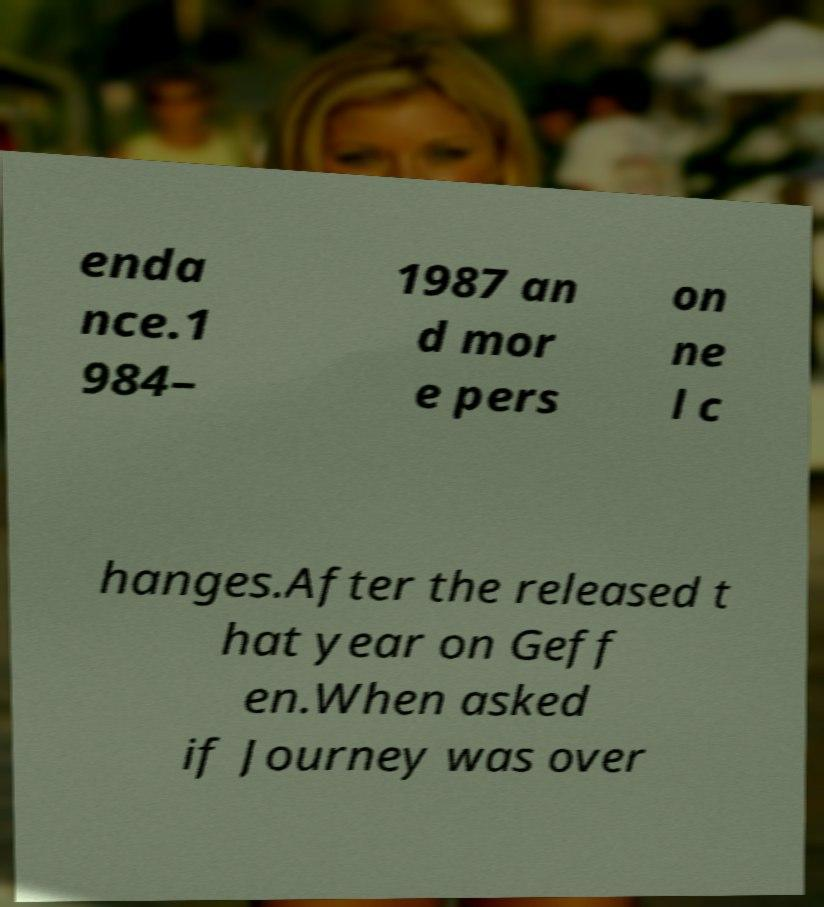I need the written content from this picture converted into text. Can you do that? enda nce.1 984– 1987 an d mor e pers on ne l c hanges.After the released t hat year on Geff en.When asked if Journey was over 